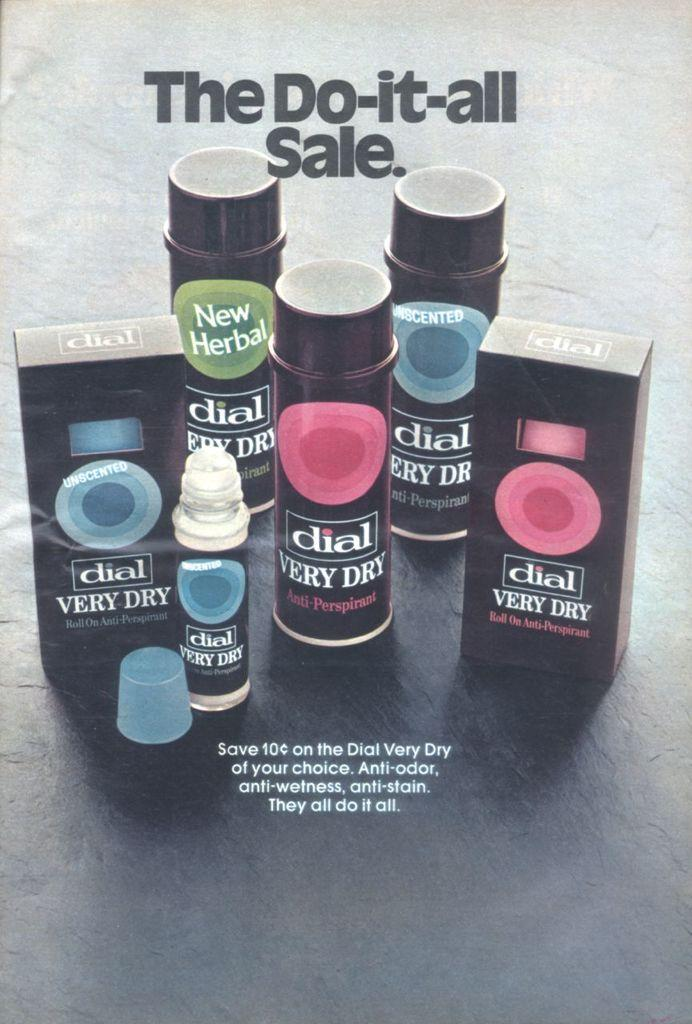<image>
Create a compact narrative representing the image presented. An ad for Dial soap shows several examples of the product. 